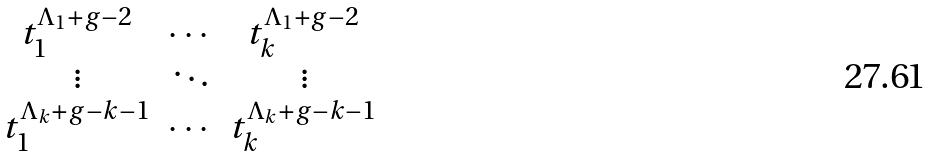<formula> <loc_0><loc_0><loc_500><loc_500>\begin{matrix} t _ { 1 } ^ { \Lambda _ { 1 } + g - 2 } & \cdots & t _ { k } ^ { \Lambda _ { 1 } + g - 2 } \\ \vdots & \ddots & \vdots \\ t _ { 1 } ^ { \Lambda _ { k } + g - k - 1 } & \cdots & t _ { k } ^ { \Lambda _ { k } + g - k - 1 } \\ \end{matrix}</formula> 